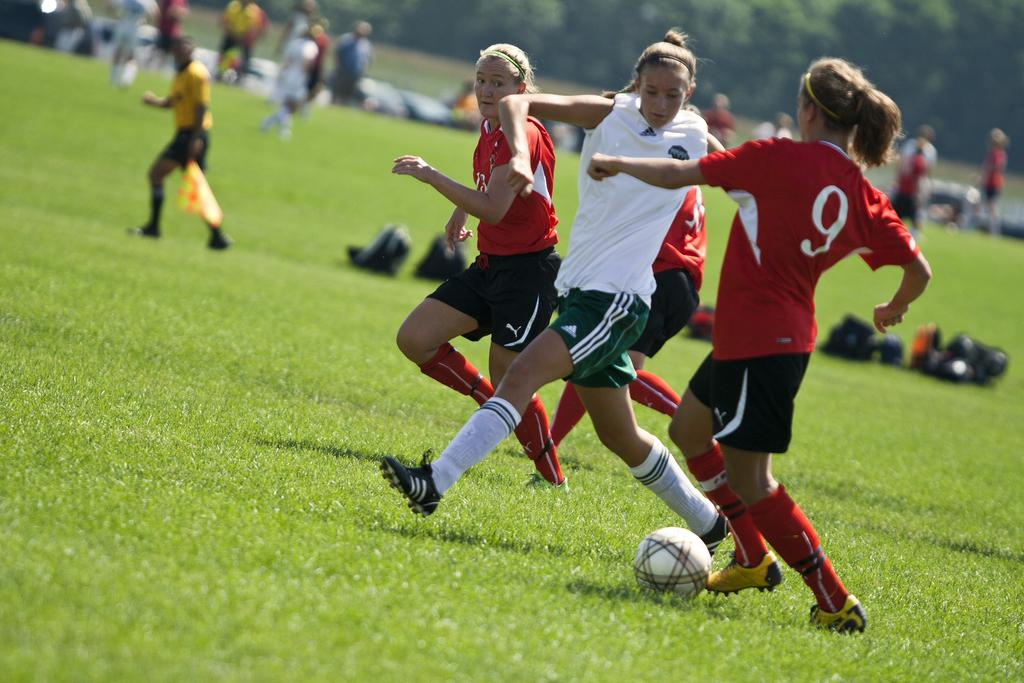<image>
Describe the image concisely. Player number 9 kicks the ball down the field away from her opponent 